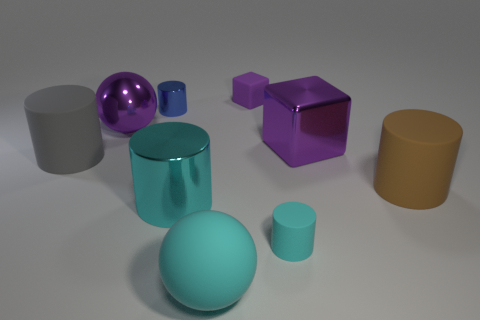Are there any big spheres of the same color as the big cube?
Offer a very short reply. Yes. There is a purple block that is in front of the blue cylinder; is it the same size as the big brown matte cylinder?
Make the answer very short. Yes. Are there an equal number of cyan spheres that are to the right of the brown thing and purple metal balls?
Offer a very short reply. No. What number of things are either cylinders that are left of the tiny cube or big gray matte cubes?
Your response must be concise. 3. What shape is the purple object that is both in front of the small purple cube and left of the purple metal block?
Your answer should be compact. Sphere. How many objects are small cyan matte cylinders in front of the large purple sphere or big purple things on the left side of the small cyan rubber cylinder?
Your answer should be very brief. 2. How many other things are there of the same size as the metallic sphere?
Offer a very short reply. 5. Do the tiny rubber object on the right side of the rubber cube and the metal ball have the same color?
Your answer should be very brief. No. There is a metal object that is both behind the big gray cylinder and to the right of the small blue object; what is its size?
Provide a succinct answer. Large. What number of big objects are either cyan rubber cylinders or purple balls?
Provide a short and direct response. 1. 